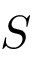Convert formula to latex. <formula><loc_0><loc_0><loc_500><loc_500>S</formula> 